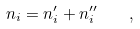Convert formula to latex. <formula><loc_0><loc_0><loc_500><loc_500>n _ { i } = n _ { i } ^ { \prime } + n _ { i } ^ { \prime \prime } \quad ,</formula> 